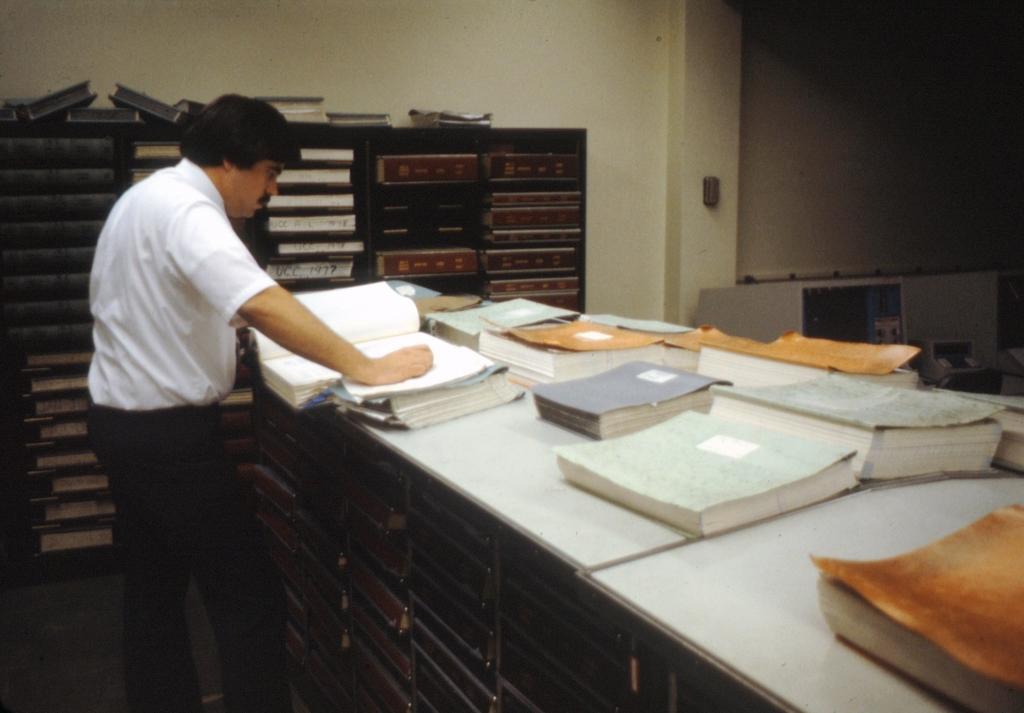Describe this image in one or two sentences. In this picture we can see man standing and in front of him there is table full of books and beside to him we have racks, wall, pillar. 